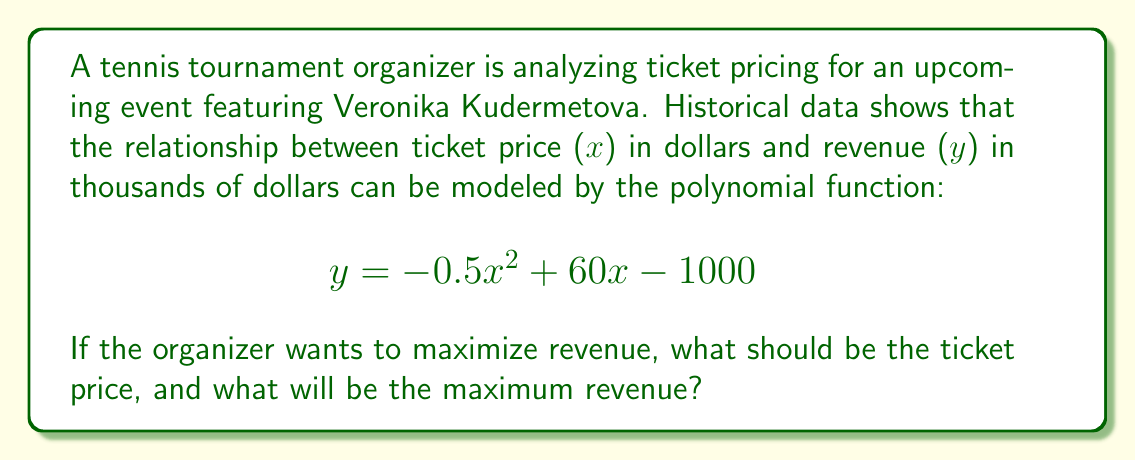Help me with this question. To find the maximum revenue, we need to follow these steps:

1) The given polynomial function is quadratic, with a negative leading coefficient. This means it forms a parabola that opens downward and has a maximum point.

2) To find the maximum point, we need to find the vertex of the parabola. For a quadratic function in the form $f(x) = ax^2 + bx + c$, the x-coordinate of the vertex is given by $x = -\frac{b}{2a}$.

3) In our case, $a = -0.5$, $b = 60$, and $c = -1000$. Let's substitute these values:

   $$x = -\frac{60}{2(-0.5)} = -\frac{60}{-1} = 60$$

4) This means the optimal ticket price is $60.

5) To find the maximum revenue, we need to substitute this x-value back into our original function:

   $$y = -0.5(60)^2 + 60(60) - 1000$$
   $$= -0.5(3600) + 3600 - 1000$$
   $$= -1800 + 3600 - 1000$$
   $$= 800$$

6) Therefore, the maximum revenue is $800,000 (remember, y was in thousands of dollars).
Answer: The optimal ticket price is $60, and the maximum revenue is $800,000. 